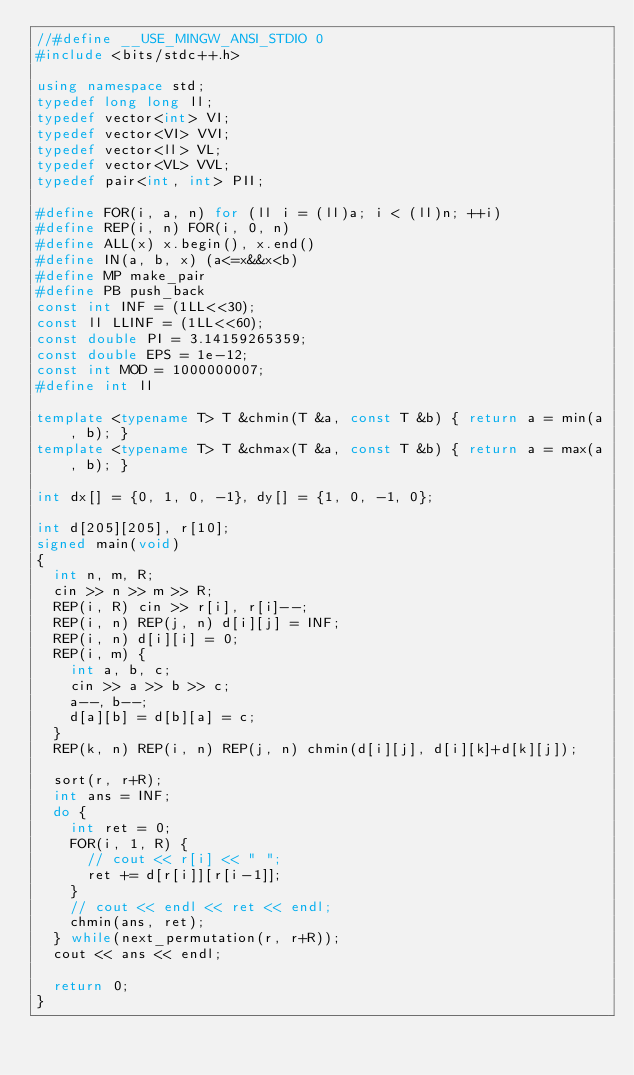Convert code to text. <code><loc_0><loc_0><loc_500><loc_500><_C++_>//#define __USE_MINGW_ANSI_STDIO 0
#include <bits/stdc++.h>

using namespace std;
typedef long long ll;
typedef vector<int> VI;
typedef vector<VI> VVI;
typedef vector<ll> VL;
typedef vector<VL> VVL;
typedef pair<int, int> PII;

#define FOR(i, a, n) for (ll i = (ll)a; i < (ll)n; ++i)
#define REP(i, n) FOR(i, 0, n)
#define ALL(x) x.begin(), x.end()
#define IN(a, b, x) (a<=x&&x<b)
#define MP make_pair
#define PB push_back
const int INF = (1LL<<30);
const ll LLINF = (1LL<<60);
const double PI = 3.14159265359;
const double EPS = 1e-12;
const int MOD = 1000000007;
#define int ll

template <typename T> T &chmin(T &a, const T &b) { return a = min(a, b); }
template <typename T> T &chmax(T &a, const T &b) { return a = max(a, b); }

int dx[] = {0, 1, 0, -1}, dy[] = {1, 0, -1, 0};

int d[205][205], r[10];
signed main(void)
{
  int n, m, R;
  cin >> n >> m >> R;
  REP(i, R) cin >> r[i], r[i]--;
  REP(i, n) REP(j, n) d[i][j] = INF;
  REP(i, n) d[i][i] = 0;
  REP(i, m) {
    int a, b, c;
    cin >> a >> b >> c;
    a--, b--;
    d[a][b] = d[b][a] = c;
  }
  REP(k, n) REP(i, n) REP(j, n) chmin(d[i][j], d[i][k]+d[k][j]);

  sort(r, r+R);
  int ans = INF;
  do {
    int ret = 0;
    FOR(i, 1, R) {
      // cout << r[i] << " ";
      ret += d[r[i]][r[i-1]];
    }
    // cout << endl << ret << endl;
    chmin(ans, ret);
  } while(next_permutation(r, r+R));
  cout << ans << endl;

  return 0;
}
</code> 